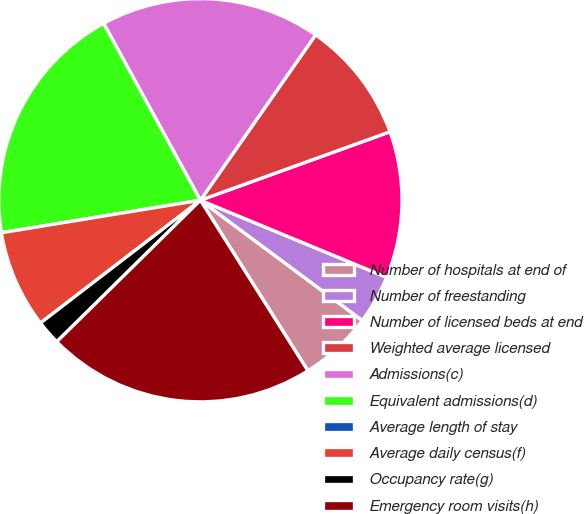Convert chart to OTSL. <chart><loc_0><loc_0><loc_500><loc_500><pie_chart><fcel>Number of hospitals at end of<fcel>Number of freestanding<fcel>Number of licensed beds at end<fcel>Weighted average licensed<fcel>Admissions(c)<fcel>Equivalent admissions(d)<fcel>Average length of stay<fcel>Average daily census(f)<fcel>Occupancy rate(g)<fcel>Emergency room visits(h)<nl><fcel>5.88%<fcel>3.92%<fcel>11.76%<fcel>9.8%<fcel>17.65%<fcel>19.61%<fcel>0.0%<fcel>7.84%<fcel>1.96%<fcel>21.57%<nl></chart> 